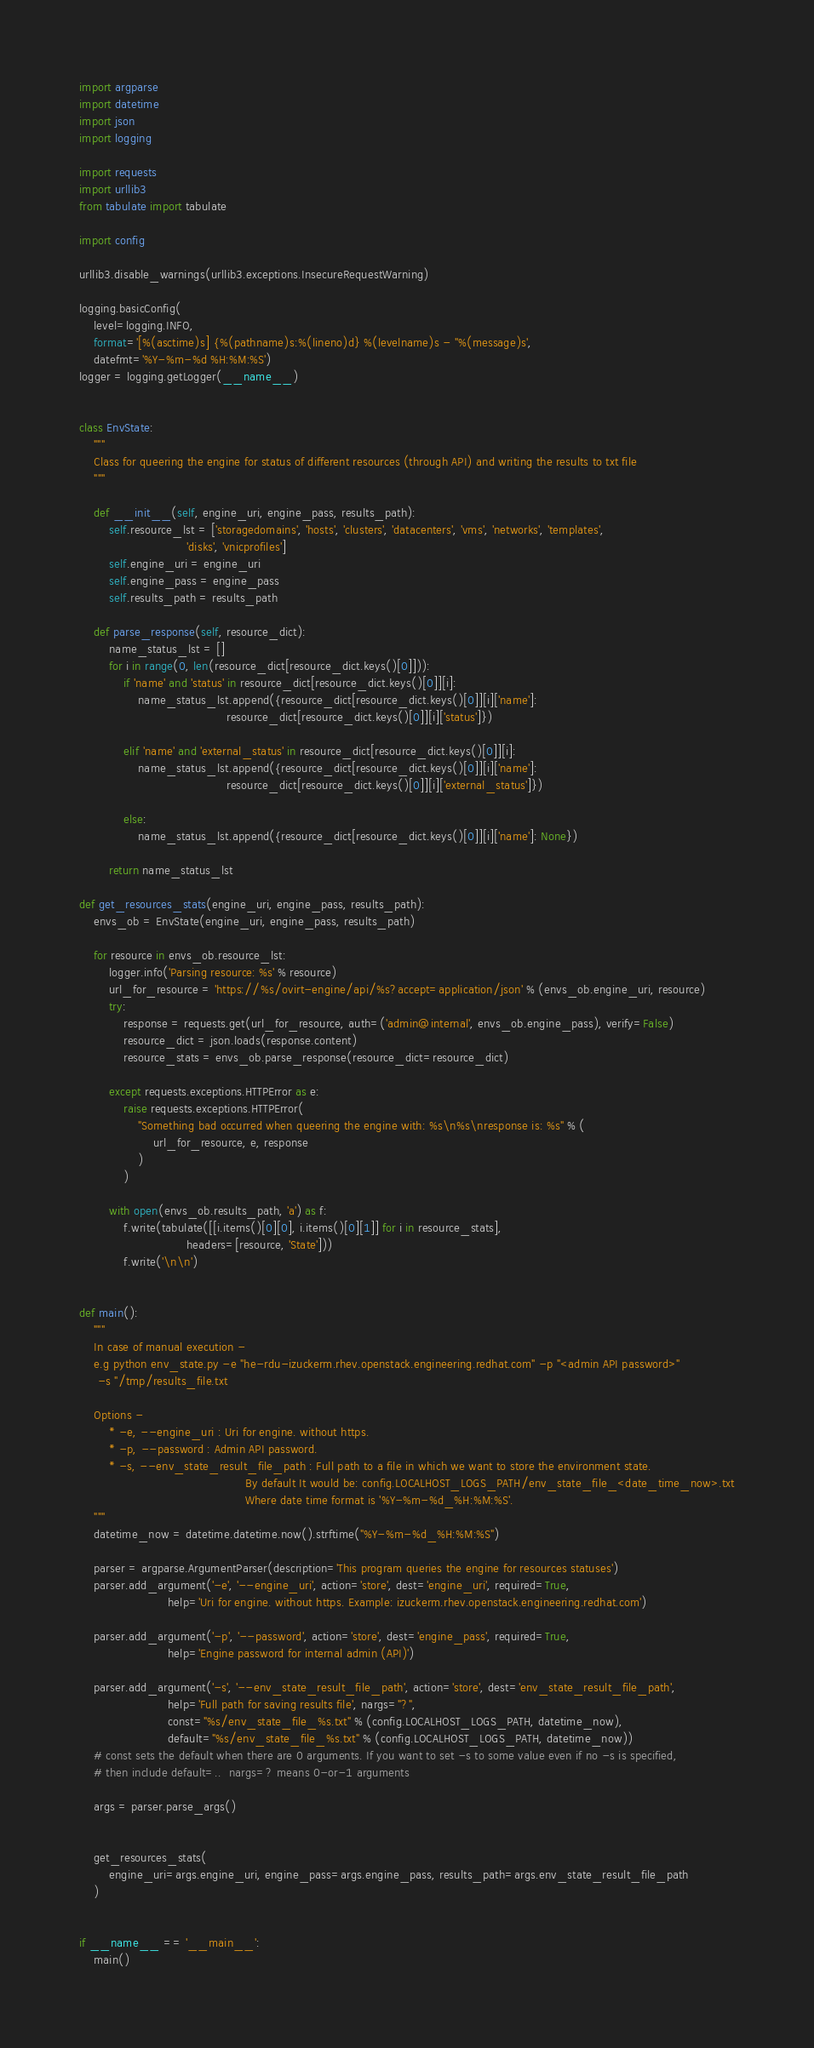<code> <loc_0><loc_0><loc_500><loc_500><_Python_>import argparse
import datetime
import json
import logging

import requests
import urllib3
from tabulate import tabulate

import config

urllib3.disable_warnings(urllib3.exceptions.InsecureRequestWarning)

logging.basicConfig(
    level=logging.INFO,
    format='[%(asctime)s] {%(pathname)s:%(lineno)d} %(levelname)s - ''%(message)s',
    datefmt='%Y-%m-%d %H:%M:%S')
logger = logging.getLogger(__name__)


class EnvState:
    """
    Class for queering the engine for status of different resources (through API) and writing the results to txt file
    """

    def __init__(self, engine_uri, engine_pass, results_path):
        self.resource_lst = ['storagedomains', 'hosts', 'clusters', 'datacenters', 'vms', 'networks', 'templates',
                             'disks', 'vnicprofiles']
        self.engine_uri = engine_uri
        self.engine_pass = engine_pass
        self.results_path = results_path

    def parse_response(self, resource_dict):
        name_status_lst = []
        for i in range(0, len(resource_dict[resource_dict.keys()[0]])):
            if 'name' and 'status' in resource_dict[resource_dict.keys()[0]][i]:
                name_status_lst.append({resource_dict[resource_dict.keys()[0]][i]['name']:
                                        resource_dict[resource_dict.keys()[0]][i]['status']})

            elif 'name' and 'external_status' in resource_dict[resource_dict.keys()[0]][i]:
                name_status_lst.append({resource_dict[resource_dict.keys()[0]][i]['name']:
                                        resource_dict[resource_dict.keys()[0]][i]['external_status']})

            else:
                name_status_lst.append({resource_dict[resource_dict.keys()[0]][i]['name']: None})

        return name_status_lst

def get_resources_stats(engine_uri, engine_pass, results_path):
    envs_ob = EnvState(engine_uri, engine_pass, results_path)

    for resource in envs_ob.resource_lst:
        logger.info('Parsing resource: %s' % resource)
        url_for_resource = 'https://%s/ovirt-engine/api/%s?accept=application/json' % (envs_ob.engine_uri, resource)
        try:
            response = requests.get(url_for_resource, auth=('admin@internal', envs_ob.engine_pass), verify=False)
            resource_dict = json.loads(response.content)
            resource_stats = envs_ob.parse_response(resource_dict=resource_dict)

        except requests.exceptions.HTTPError as e:
            raise requests.exceptions.HTTPError(
                "Something bad occurred when queering the engine with: %s\n%s\nresponse is: %s" % (
                    url_for_resource, e, response
                )
            )

        with open(envs_ob.results_path, 'a') as f:
            f.write(tabulate([[i.items()[0][0], i.items()[0][1]] for i in resource_stats],
                             headers=[resource, 'State']))
            f.write('\n\n')


def main():
    """
    In case of manual execution -
    e.g python env_state.py -e "he-rdu-izuckerm.rhev.openstack.engineering.redhat.com" -p "<admin API password>"
     -s "/tmp/results_file.txt

    Options -
        * -e, --engine_uri : Uri for engine. without https.
        * -p, --password : Admin API password.
        * -s, --env_state_result_file_path : Full path to a file in which we want to store the environment state.
                                             By default It would be: config.LOCALHOST_LOGS_PATH/env_state_file_<date_time_now>.txt
                                             Where date time format is '%Y-%m-%d_%H:%M:%S'.
    """
    datetime_now = datetime.datetime.now().strftime("%Y-%m-%d_%H:%M:%S")

    parser = argparse.ArgumentParser(description='This program queries the engine for resources statuses')
    parser.add_argument('-e', '--engine_uri', action='store', dest='engine_uri', required=True,
                        help='Uri for engine. without https. Example: izuckerm.rhev.openstack.engineering.redhat.com')

    parser.add_argument('-p', '--password', action='store', dest='engine_pass', required=True,
                        help='Engine password for internal admin (API)')

    parser.add_argument('-s', '--env_state_result_file_path', action='store', dest='env_state_result_file_path',
                        help='Full path for saving results file', nargs="?",
                        const="%s/env_state_file_%s.txt" % (config.LOCALHOST_LOGS_PATH, datetime_now),
                        default="%s/env_state_file_%s.txt" % (config.LOCALHOST_LOGS_PATH, datetime_now))
    # const sets the default when there are 0 arguments. If you want to set -s to some value even if no -s is specified,
    # then include default=..  nargs=? means 0-or-1 arguments

    args = parser.parse_args()


    get_resources_stats(
        engine_uri=args.engine_uri, engine_pass=args.engine_pass, results_path=args.env_state_result_file_path
    )


if __name__ == '__main__':
    main()
</code> 